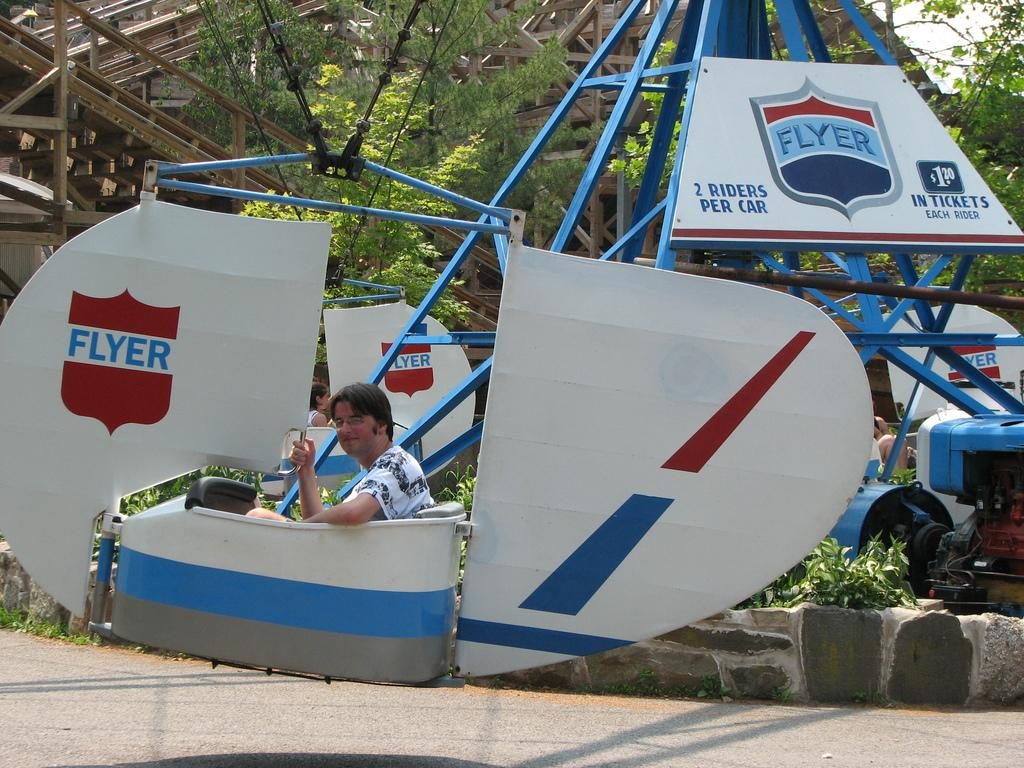Provide a one-sentence caption for the provided image. Man sitting inside of a ride that is called FLYER. 